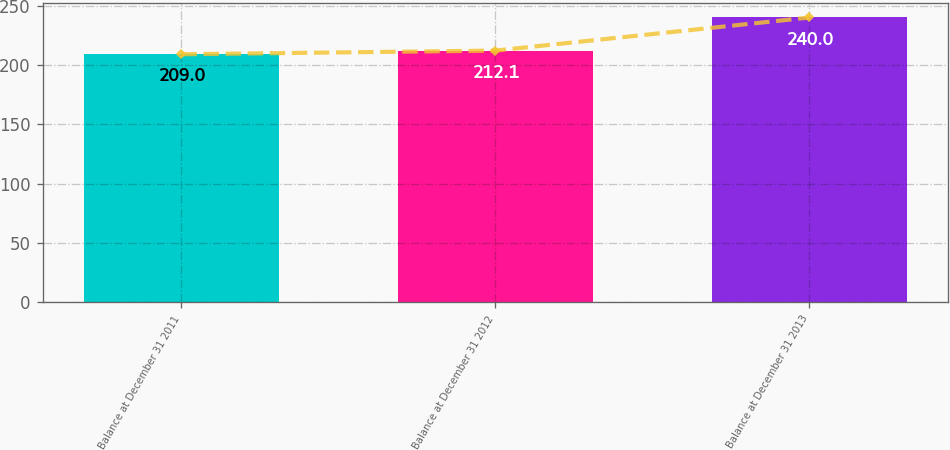Convert chart. <chart><loc_0><loc_0><loc_500><loc_500><bar_chart><fcel>Balance at December 31 2011<fcel>Balance at December 31 2012<fcel>Balance at December 31 2013<nl><fcel>209<fcel>212.1<fcel>240<nl></chart> 